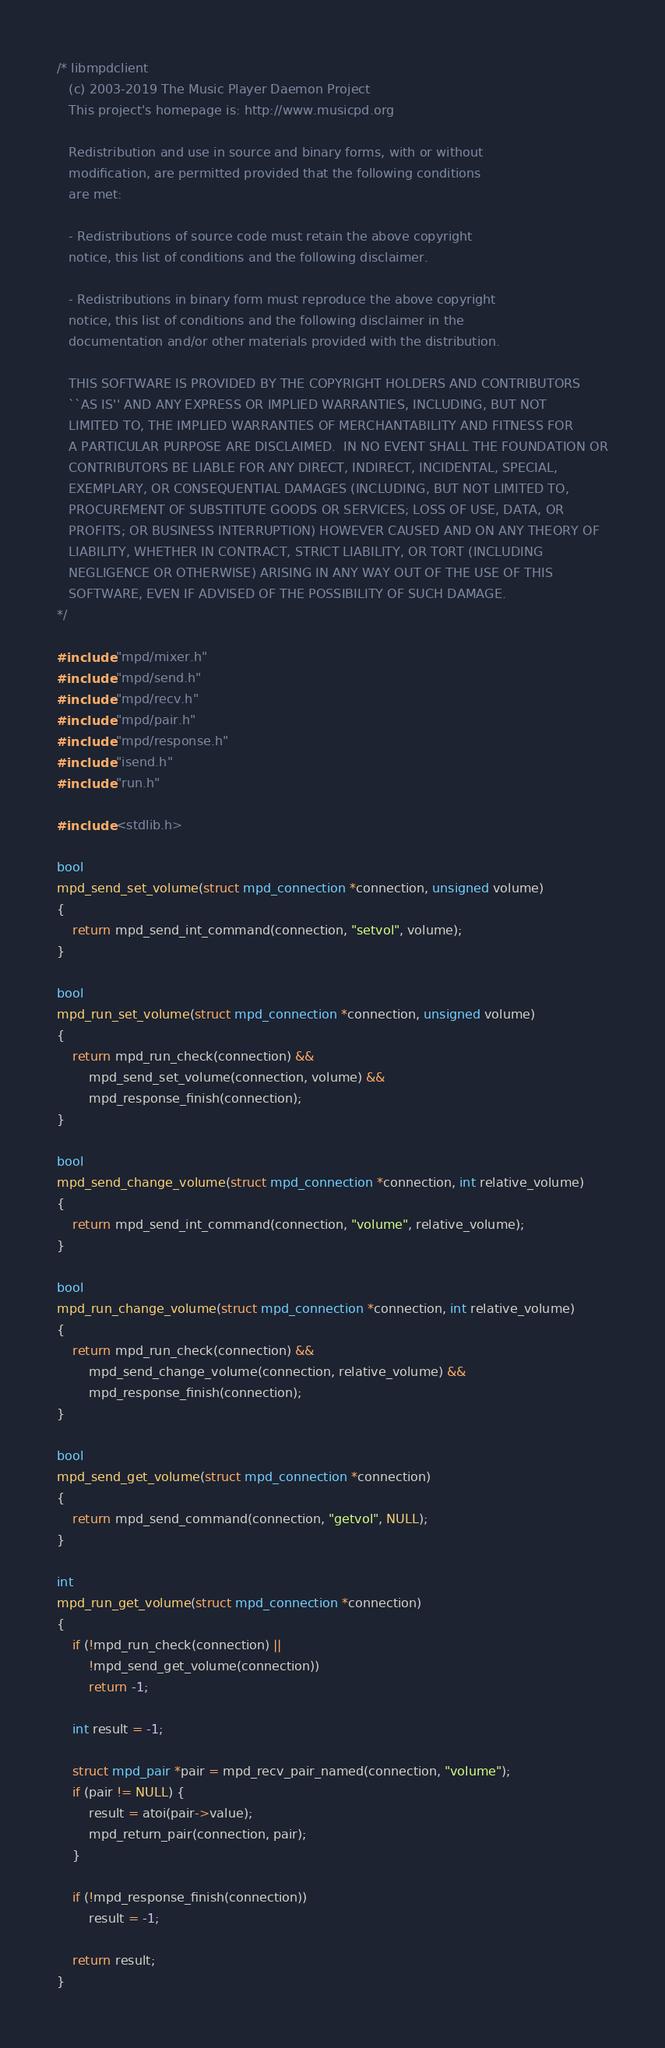<code> <loc_0><loc_0><loc_500><loc_500><_C_>/* libmpdclient
   (c) 2003-2019 The Music Player Daemon Project
   This project's homepage is: http://www.musicpd.org

   Redistribution and use in source and binary forms, with or without
   modification, are permitted provided that the following conditions
   are met:

   - Redistributions of source code must retain the above copyright
   notice, this list of conditions and the following disclaimer.

   - Redistributions in binary form must reproduce the above copyright
   notice, this list of conditions and the following disclaimer in the
   documentation and/or other materials provided with the distribution.

   THIS SOFTWARE IS PROVIDED BY THE COPYRIGHT HOLDERS AND CONTRIBUTORS
   ``AS IS'' AND ANY EXPRESS OR IMPLIED WARRANTIES, INCLUDING, BUT NOT
   LIMITED TO, THE IMPLIED WARRANTIES OF MERCHANTABILITY AND FITNESS FOR
   A PARTICULAR PURPOSE ARE DISCLAIMED.  IN NO EVENT SHALL THE FOUNDATION OR
   CONTRIBUTORS BE LIABLE FOR ANY DIRECT, INDIRECT, INCIDENTAL, SPECIAL,
   EXEMPLARY, OR CONSEQUENTIAL DAMAGES (INCLUDING, BUT NOT LIMITED TO,
   PROCUREMENT OF SUBSTITUTE GOODS OR SERVICES; LOSS OF USE, DATA, OR
   PROFITS; OR BUSINESS INTERRUPTION) HOWEVER CAUSED AND ON ANY THEORY OF
   LIABILITY, WHETHER IN CONTRACT, STRICT LIABILITY, OR TORT (INCLUDING
   NEGLIGENCE OR OTHERWISE) ARISING IN ANY WAY OUT OF THE USE OF THIS
   SOFTWARE, EVEN IF ADVISED OF THE POSSIBILITY OF SUCH DAMAGE.
*/

#include "mpd/mixer.h"
#include "mpd/send.h"
#include "mpd/recv.h"
#include "mpd/pair.h"
#include "mpd/response.h"
#include "isend.h"
#include "run.h"

#include <stdlib.h>

bool
mpd_send_set_volume(struct mpd_connection *connection, unsigned volume)
{
    return mpd_send_int_command(connection, "setvol", volume);
}

bool
mpd_run_set_volume(struct mpd_connection *connection, unsigned volume)
{
    return mpd_run_check(connection) &&
        mpd_send_set_volume(connection, volume) &&
        mpd_response_finish(connection);
}

bool
mpd_send_change_volume(struct mpd_connection *connection, int relative_volume)
{
    return mpd_send_int_command(connection, "volume", relative_volume);
}

bool
mpd_run_change_volume(struct mpd_connection *connection, int relative_volume)
{
    return mpd_run_check(connection) &&
        mpd_send_change_volume(connection, relative_volume) &&
        mpd_response_finish(connection);
}

bool
mpd_send_get_volume(struct mpd_connection *connection)
{
    return mpd_send_command(connection, "getvol", NULL);
}

int
mpd_run_get_volume(struct mpd_connection *connection)
{
    if (!mpd_run_check(connection) ||
        !mpd_send_get_volume(connection))
        return -1;

    int result = -1;

    struct mpd_pair *pair = mpd_recv_pair_named(connection, "volume");
    if (pair != NULL) {
        result = atoi(pair->value);
        mpd_return_pair(connection, pair);
    }

    if (!mpd_response_finish(connection))
        result = -1;

    return result;
}
</code> 